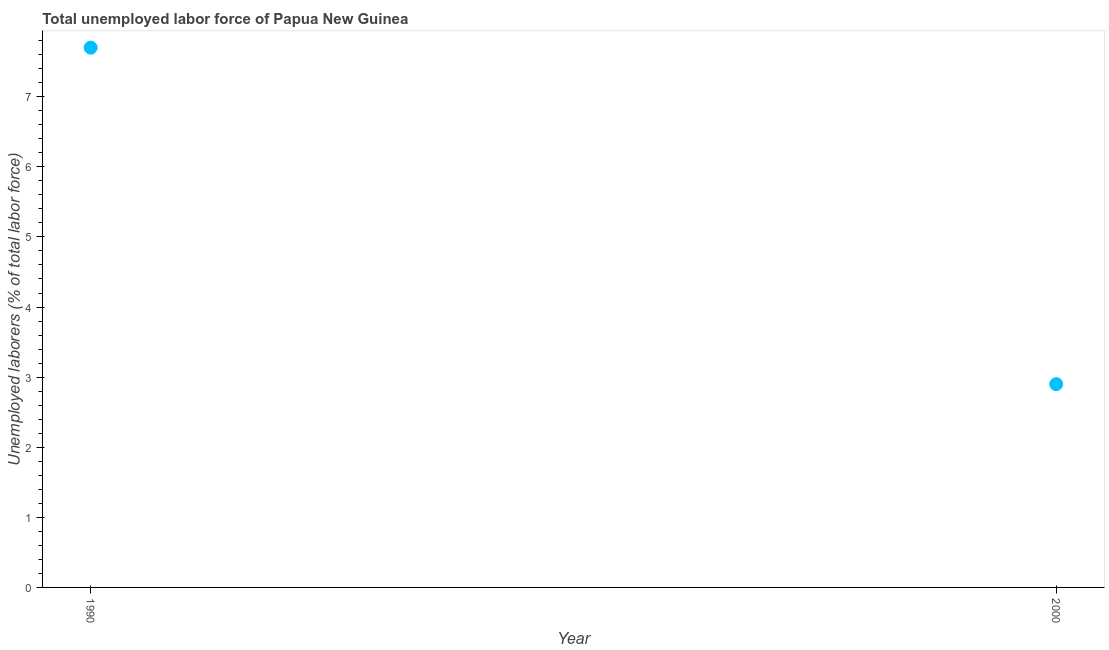What is the total unemployed labour force in 1990?
Give a very brief answer. 7.7. Across all years, what is the maximum total unemployed labour force?
Offer a terse response. 7.7. Across all years, what is the minimum total unemployed labour force?
Keep it short and to the point. 2.9. What is the sum of the total unemployed labour force?
Provide a short and direct response. 10.6. What is the difference between the total unemployed labour force in 1990 and 2000?
Your response must be concise. 4.8. What is the average total unemployed labour force per year?
Provide a succinct answer. 5.3. What is the median total unemployed labour force?
Keep it short and to the point. 5.3. What is the ratio of the total unemployed labour force in 1990 to that in 2000?
Provide a succinct answer. 2.66. Is the total unemployed labour force in 1990 less than that in 2000?
Your response must be concise. No. Does the total unemployed labour force monotonically increase over the years?
Ensure brevity in your answer.  No. How many dotlines are there?
Ensure brevity in your answer.  1. Are the values on the major ticks of Y-axis written in scientific E-notation?
Offer a very short reply. No. What is the title of the graph?
Offer a terse response. Total unemployed labor force of Papua New Guinea. What is the label or title of the Y-axis?
Ensure brevity in your answer.  Unemployed laborers (% of total labor force). What is the Unemployed laborers (% of total labor force) in 1990?
Your answer should be compact. 7.7. What is the Unemployed laborers (% of total labor force) in 2000?
Provide a succinct answer. 2.9. What is the ratio of the Unemployed laborers (% of total labor force) in 1990 to that in 2000?
Ensure brevity in your answer.  2.65. 